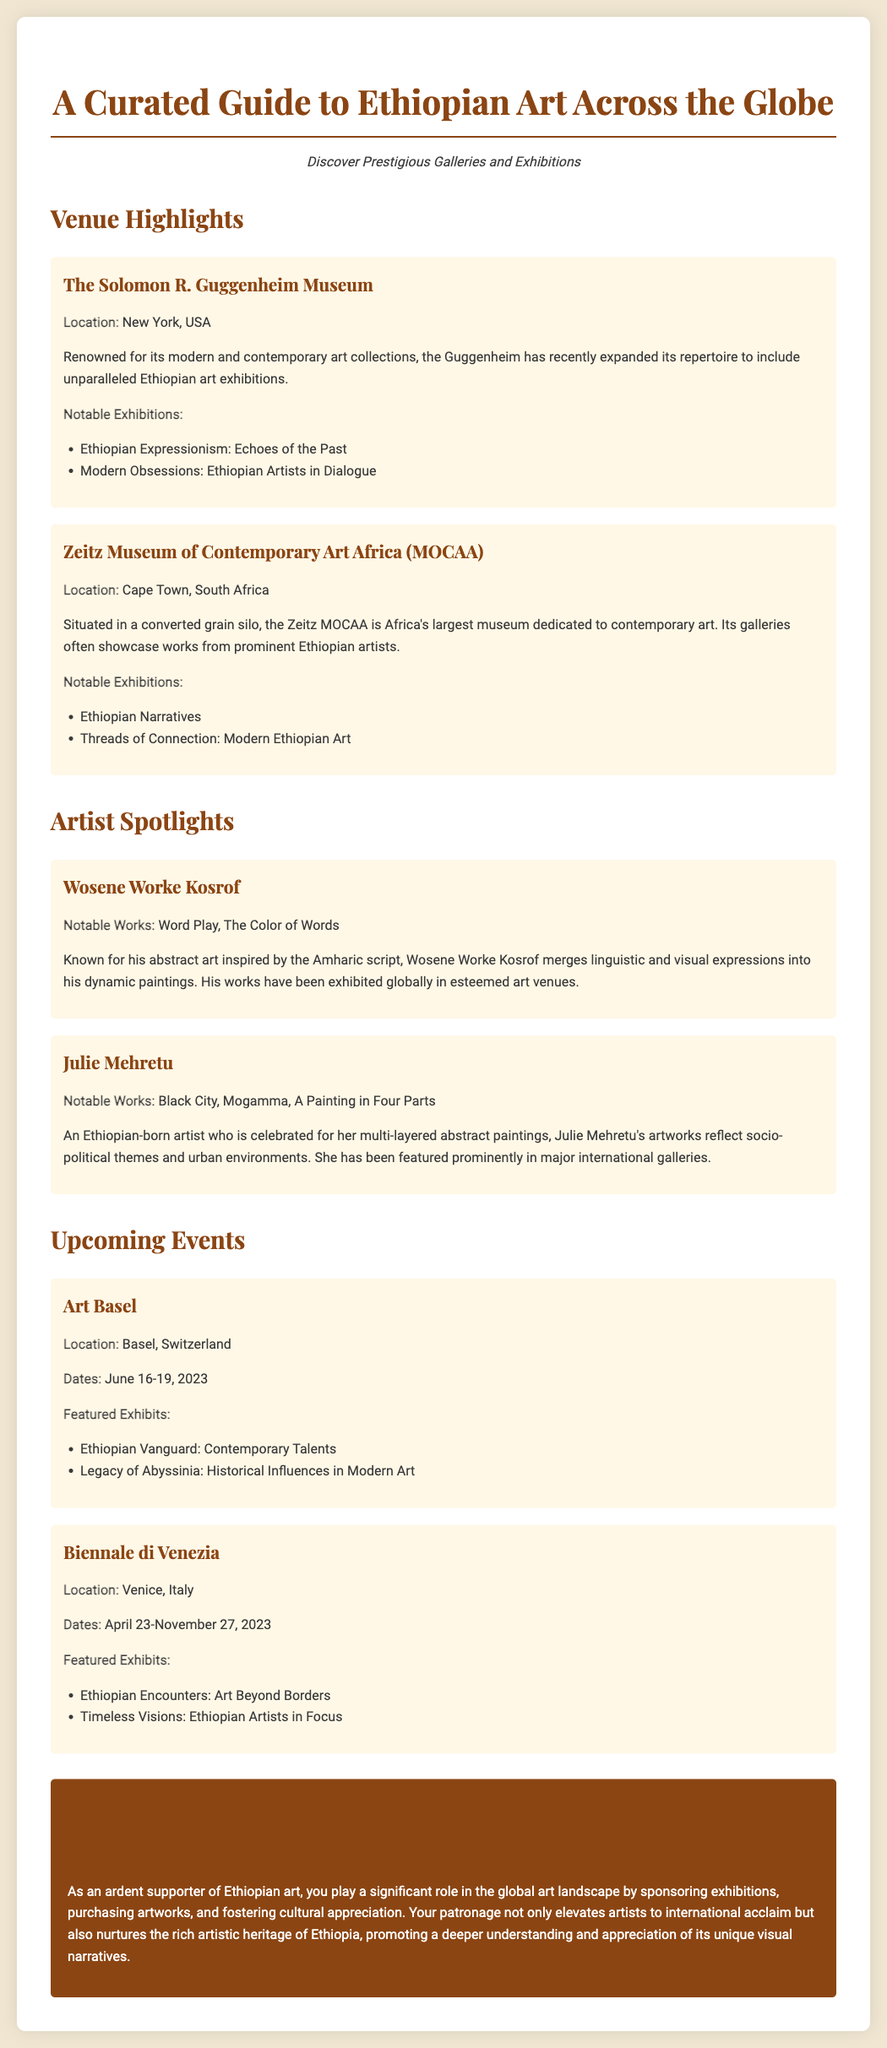What is the title of the guide? The title is displayed prominently at the top of the document, indicating the subject matter it covers.
Answer: A Curated Guide to Ethiopian Art Across the Globe Which museum is located in New York, USA? The document highlights venues and provides specific locations, naming the museum situated in New York.
Answer: The Solomon R. Guggenheim Museum What notable exhibition is featured at the Zeitz MOCAA? The document lists exhibitions under the venue section, showcasing significant exhibitions at each listed venue.
Answer: Ethiopian Narratives Who is the artist known for "Black City"? The artist spotlights provide notable works along with the names of the artists associated with them.
Answer: Julie Mehretu What are the dates for the Biennale di Venezia? The document provides specific dates for upcoming events, including their durations.
Answer: April 23-November 27, 2023 Which city hosts Art Basel? Each event listed in the document is accompanied by its specific location, indicating where the event takes place.
Answer: Basel, Switzerland How many notable works are listed for Wosene Worke Kosrof? The artist spotlight section details the works of each featured artist, allowing us to count them.
Answer: Two What is the subtitle of the document? The subtitle is mentioned to give additional context to the main title, enhancing understanding of the document's focus.
Answer: Discover Prestigious Galleries and Exhibitions 